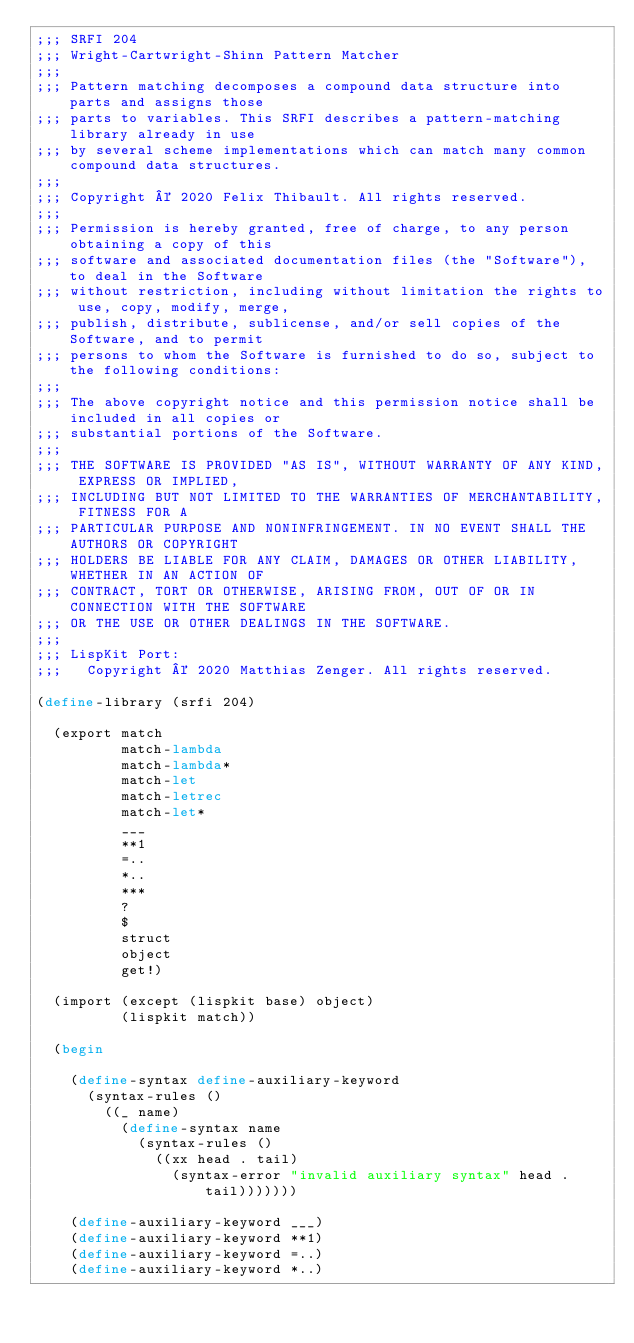Convert code to text. <code><loc_0><loc_0><loc_500><loc_500><_Scheme_>;;; SRFI 204
;;; Wright-Cartwright-Shinn Pattern Matcher
;;;
;;; Pattern matching decomposes a compound data structure into parts and assigns those
;;; parts to variables. This SRFI describes a pattern-matching library already in use
;;; by several scheme implementations which can match many common compound data structures.
;;;
;;; Copyright © 2020 Felix Thibault. All rights reserved.
;;;
;;; Permission is hereby granted, free of charge, to any person obtaining a copy of this
;;; software and associated documentation files (the "Software"), to deal in the Software
;;; without restriction, including without limitation the rights to use, copy, modify, merge,
;;; publish, distribute, sublicense, and/or sell copies of the Software, and to permit
;;; persons to whom the Software is furnished to do so, subject to the following conditions:
;;;
;;; The above copyright notice and this permission notice shall be included in all copies or
;;; substantial portions of the Software.
;;;
;;; THE SOFTWARE IS PROVIDED "AS IS", WITHOUT WARRANTY OF ANY KIND, EXPRESS OR IMPLIED,
;;; INCLUDING BUT NOT LIMITED TO THE WARRANTIES OF MERCHANTABILITY, FITNESS FOR A
;;; PARTICULAR PURPOSE AND NONINFRINGEMENT. IN NO EVENT SHALL THE AUTHORS OR COPYRIGHT
;;; HOLDERS BE LIABLE FOR ANY CLAIM, DAMAGES OR OTHER LIABILITY, WHETHER IN AN ACTION OF
;;; CONTRACT, TORT OR OTHERWISE, ARISING FROM, OUT OF OR IN CONNECTION WITH THE SOFTWARE
;;; OR THE USE OR OTHER DEALINGS IN THE SOFTWARE.
;;;
;;; LispKit Port:
;;;   Copyright © 2020 Matthias Zenger. All rights reserved.

(define-library (srfi 204)
  
  (export match
          match-lambda
          match-lambda*
          match-let
          match-letrec
          match-let*
          ___
          **1
          =..
          *..
          ***
          ?
          $
          struct
          object
          get!)
  
  (import (except (lispkit base) object)
          (lispkit match))
  
  (begin
    
    (define-syntax define-auxiliary-keyword
      (syntax-rules ()
        ((_ name)
          (define-syntax name
            (syntax-rules ()
              ((xx head . tail)
                (syntax-error "invalid auxiliary syntax" head . tail)))))))
    
    (define-auxiliary-keyword ___)
    (define-auxiliary-keyword **1)
    (define-auxiliary-keyword =..)
    (define-auxiliary-keyword *..)</code> 